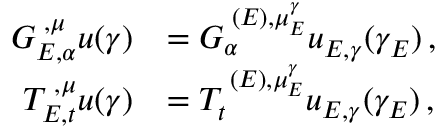Convert formula to latex. <formula><loc_0><loc_0><loc_500><loc_500>\begin{array} { r l } { G _ { E , \alpha } ^ { { \mathbf \Upsilon } , { \mu } } u ( \gamma ) } & { = G _ { \alpha } ^ { { \mathbf \Upsilon } ( E ) , { \mu } _ { E } ^ { \gamma } } u _ { E , \gamma } ( \gamma _ { E } ) \, , } \\ { T _ { E , t } ^ { { \mathbf \Upsilon } , { \mu } } u ( \gamma ) } & { = T _ { t } ^ { { \mathbf \Upsilon } ( E ) , { \mu } _ { E } ^ { \gamma } } u _ { E , \gamma } ( \gamma _ { E } ) \, , } \end{array}</formula> 